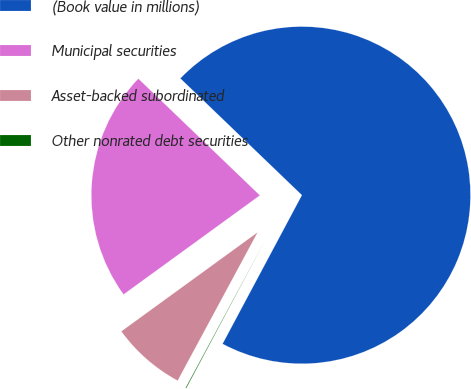Convert chart. <chart><loc_0><loc_0><loc_500><loc_500><pie_chart><fcel>(Book value in millions)<fcel>Municipal securities<fcel>Asset-backed subordinated<fcel>Other nonrated debt securities<nl><fcel>70.62%<fcel>22.18%<fcel>7.13%<fcel>0.07%<nl></chart> 